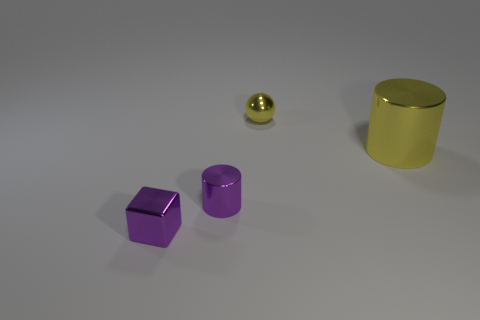Is the color of the large metallic cylinder the same as the tiny shiny sphere?
Your answer should be very brief. Yes. What number of other things are the same color as the shiny sphere?
Your response must be concise. 1. Are there any tiny shiny things of the same shape as the large object?
Give a very brief answer. Yes. What is the material of the small object that is the same color as the small cylinder?
Provide a succinct answer. Metal. There is a small object to the left of the tiny purple cylinder; what shape is it?
Ensure brevity in your answer.  Cube. How many tiny gray shiny balls are there?
Your answer should be compact. 0. What color is the big cylinder that is the same material as the tiny yellow sphere?
Make the answer very short. Yellow. What number of large things are either brown metal cylinders or purple blocks?
Give a very brief answer. 0. There is a big cylinder; how many tiny metallic blocks are in front of it?
Provide a short and direct response. 1. How many metal objects are purple objects or tiny green cubes?
Offer a very short reply. 2. 